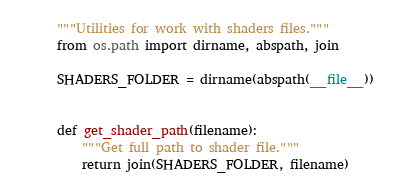<code> <loc_0><loc_0><loc_500><loc_500><_Python_>"""Utilities for work with shaders files."""
from os.path import dirname, abspath, join

SHADERS_FOLDER = dirname(abspath(__file__))


def get_shader_path(filename):
    """Get full path to shader file."""
    return join(SHADERS_FOLDER, filename)
</code> 